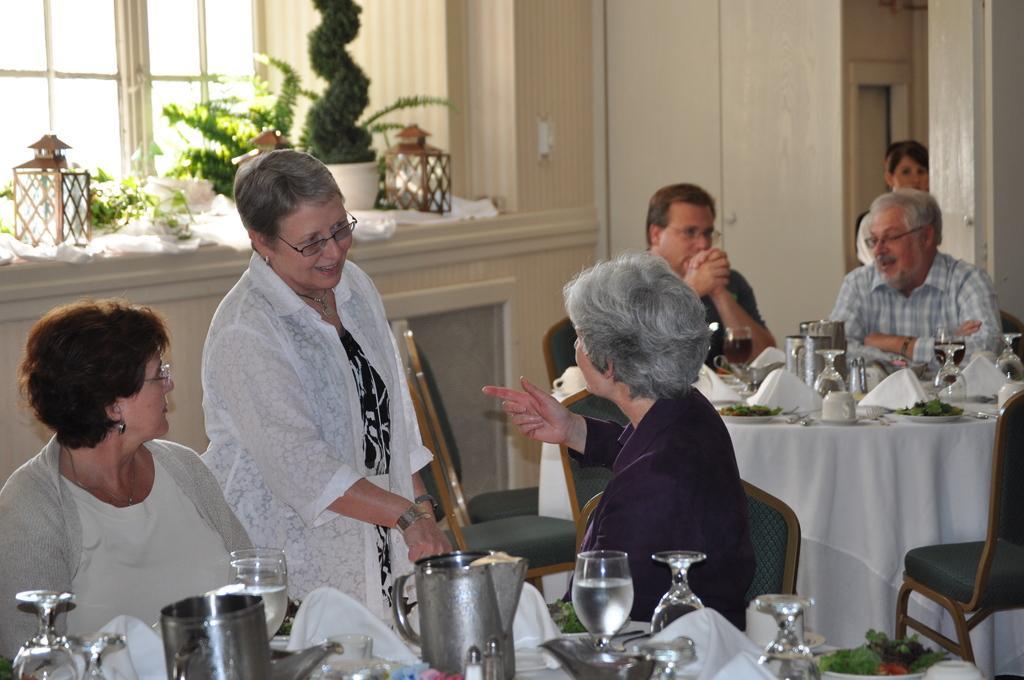Please provide a concise description of this image. In this there are three ladies and two men. The lady with white jacket is standing and she is talking. And to the left side there is a lady with white jacket is sitting. And the other lady with violet color jacket is sitting on the chair. In front of them there is a table. On the table there is a jug, glass, tissue and bowl with food item. Behind them there are two men sitting on the chair. In the background there are some pot with plants in it and a window. 